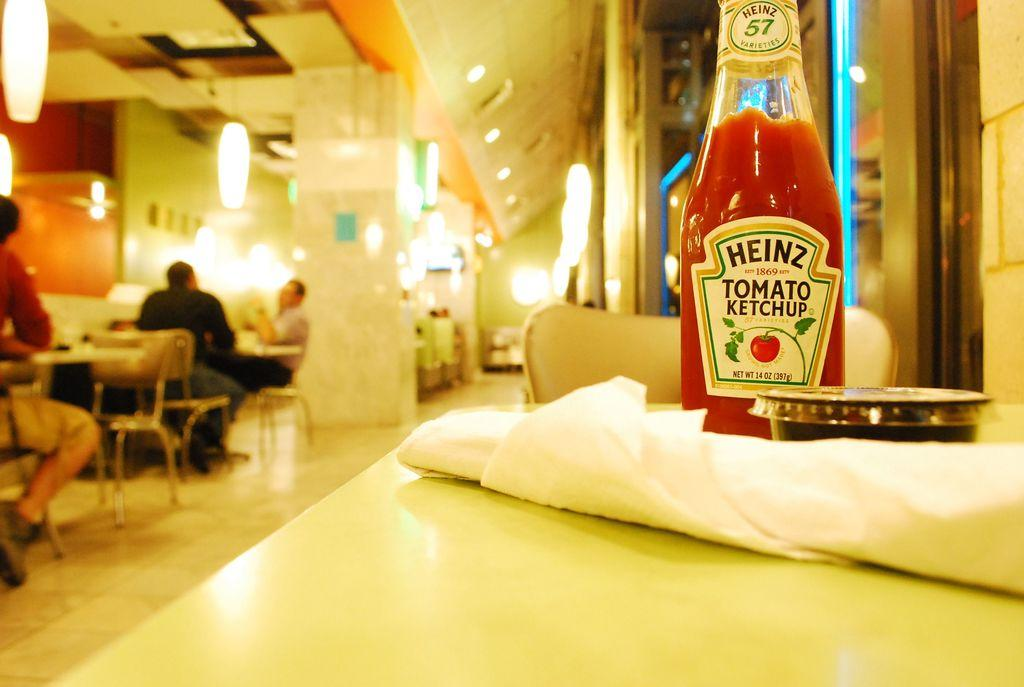What object is placed on the table in the image? There is a bottle on the table in the image. How is the bottle covered or protected? There is cloth on the bottle. What are the two persons in the image doing? The two persons are sitting on chairs. What can be seen in the image that provides illumination? There are lights visible in the image. What type of current is flowing through the owl in the image? There is no owl present in the image, and therefore no current can be flowing through it. 